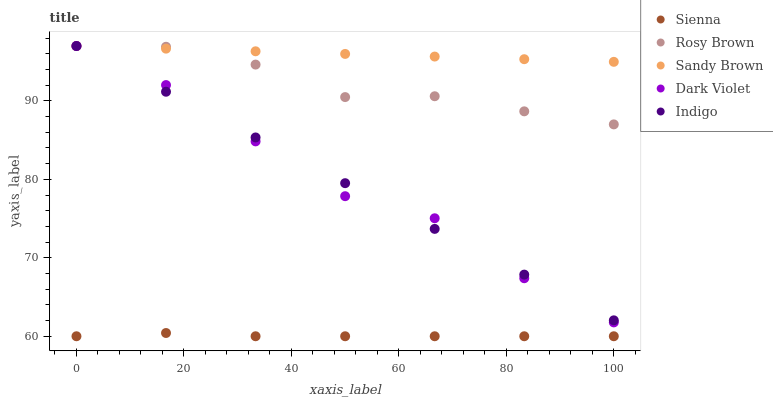Does Sienna have the minimum area under the curve?
Answer yes or no. Yes. Does Sandy Brown have the maximum area under the curve?
Answer yes or no. Yes. Does Indigo have the minimum area under the curve?
Answer yes or no. No. Does Indigo have the maximum area under the curve?
Answer yes or no. No. Is Indigo the smoothest?
Answer yes or no. Yes. Is Dark Violet the roughest?
Answer yes or no. Yes. Is Rosy Brown the smoothest?
Answer yes or no. No. Is Rosy Brown the roughest?
Answer yes or no. No. Does Sienna have the lowest value?
Answer yes or no. Yes. Does Indigo have the lowest value?
Answer yes or no. No. Does Dark Violet have the highest value?
Answer yes or no. Yes. Is Sienna less than Rosy Brown?
Answer yes or no. Yes. Is Rosy Brown greater than Sienna?
Answer yes or no. Yes. Does Rosy Brown intersect Sandy Brown?
Answer yes or no. Yes. Is Rosy Brown less than Sandy Brown?
Answer yes or no. No. Is Rosy Brown greater than Sandy Brown?
Answer yes or no. No. Does Sienna intersect Rosy Brown?
Answer yes or no. No. 